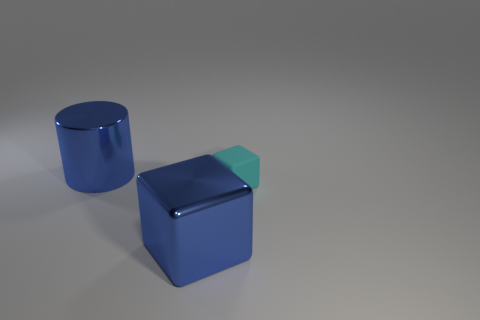Add 1 blue cylinders. How many objects exist? 4 Subtract all cylinders. How many objects are left? 2 Add 3 small cyan rubber objects. How many small cyan rubber objects are left? 4 Add 3 large blue shiny balls. How many large blue shiny balls exist? 3 Subtract 0 green spheres. How many objects are left? 3 Subtract all metal cylinders. Subtract all large brown blocks. How many objects are left? 2 